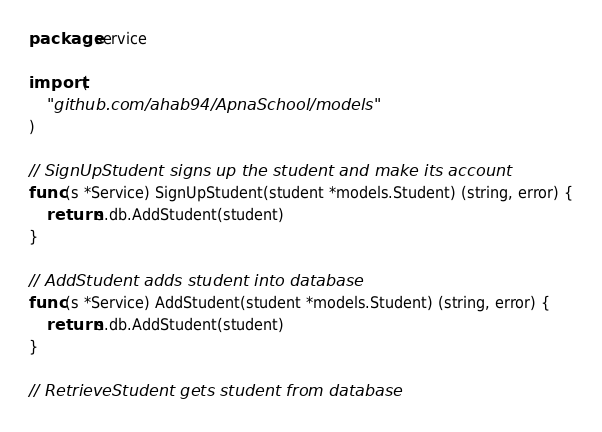<code> <loc_0><loc_0><loc_500><loc_500><_Go_>package service

import (
	"github.com/ahab94/ApnaSchool/models"
)

// SignUpStudent signs up the student and make its account
func (s *Service) SignUpStudent(student *models.Student) (string, error) {
	return s.db.AddStudent(student)
}

// AddStudent adds student into database
func (s *Service) AddStudent(student *models.Student) (string, error) {
	return s.db.AddStudent(student)
}

// RetrieveStudent gets student from database</code> 